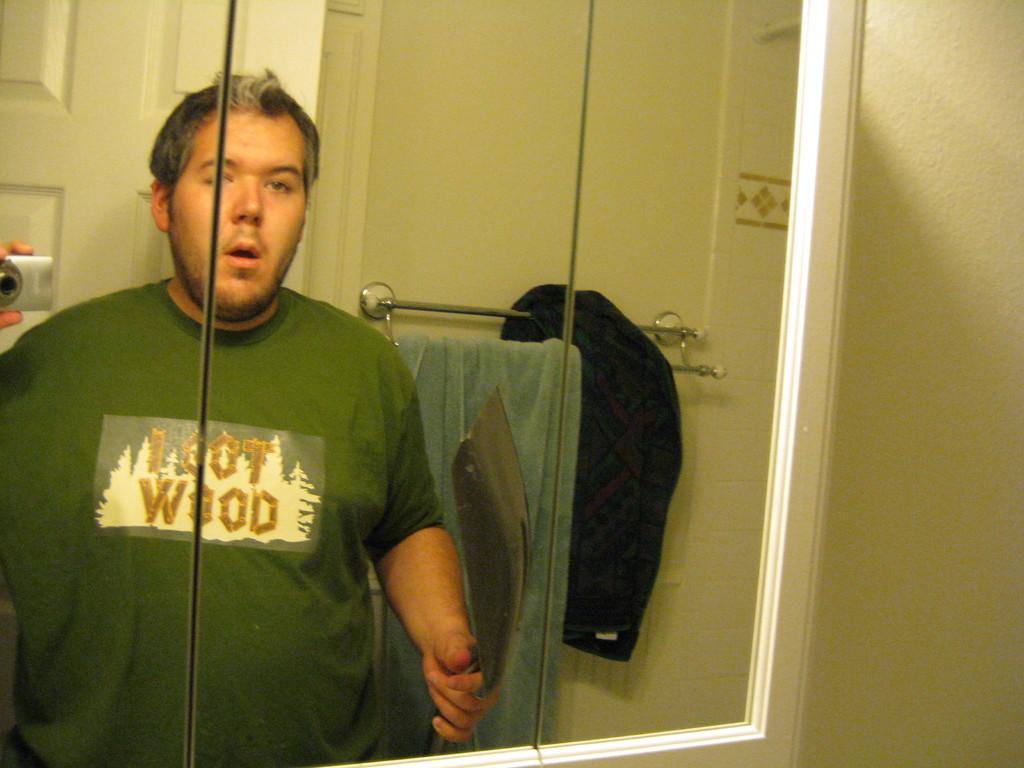<image>
Share a concise interpretation of the image provided. A man in a loot wood shirt stands in front of a mirror. 